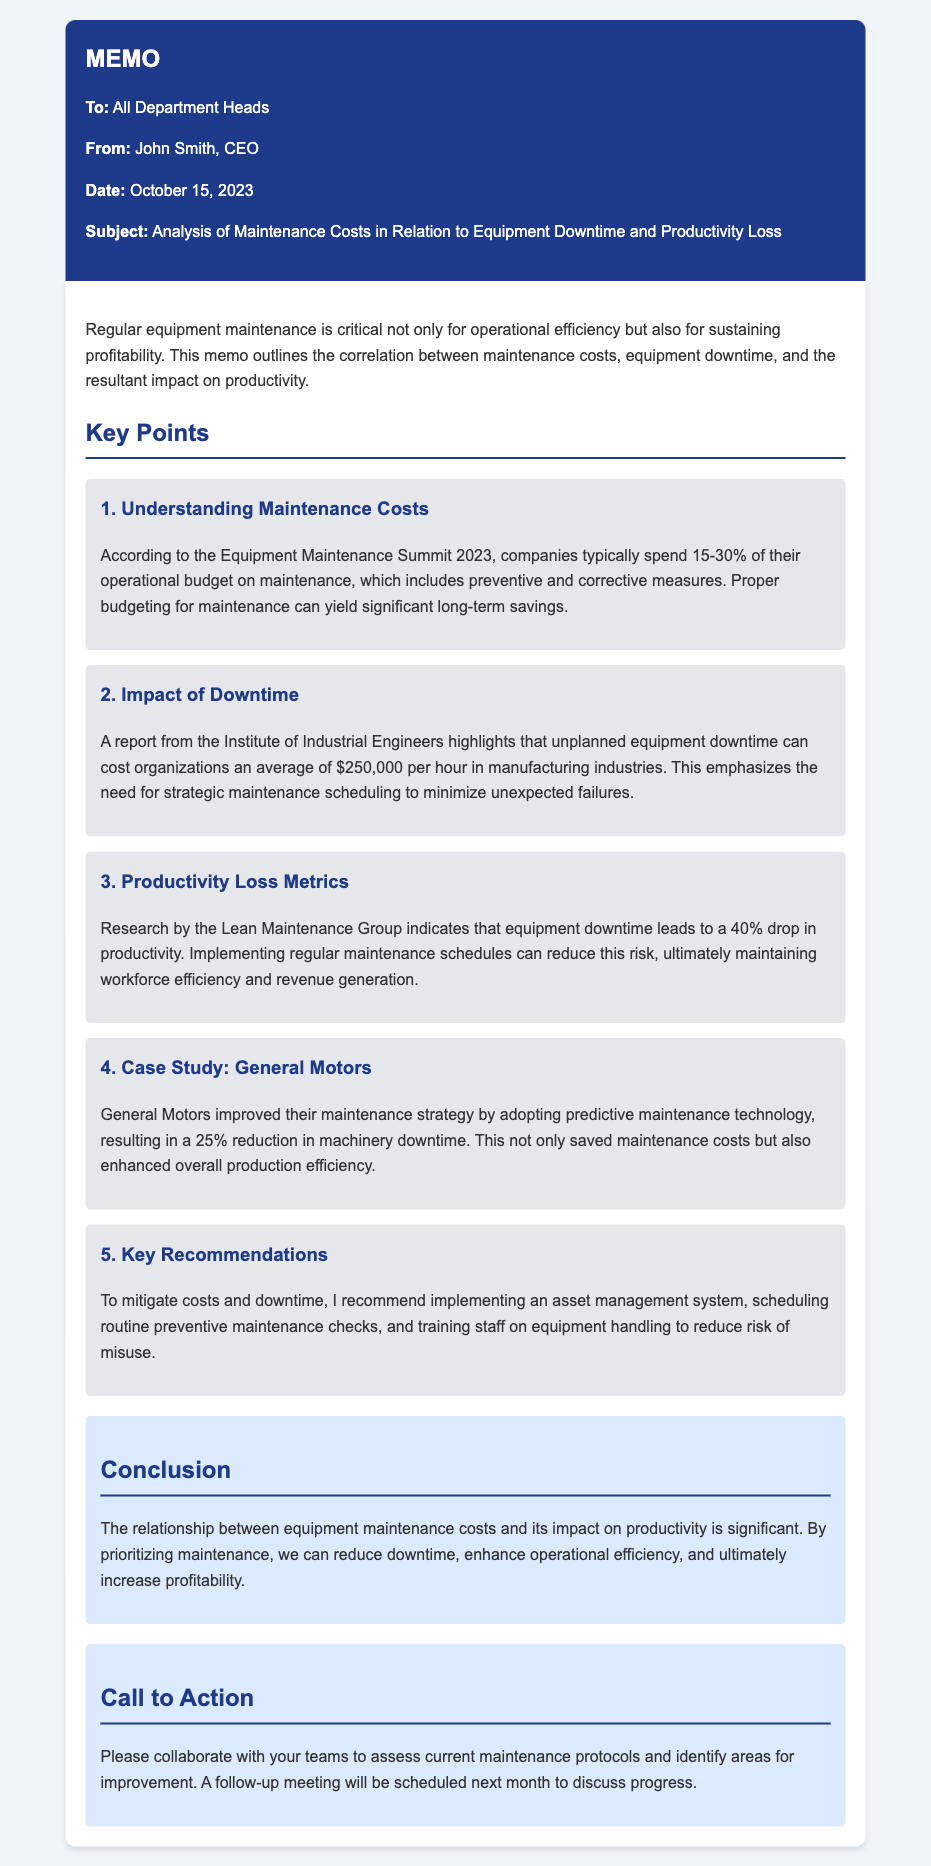What is the date of the memo? The date of the memo is mentioned in the document, which is October 15, 2023.
Answer: October 15, 2023 Who is the author of the memo? The memo states that John Smith is the author.
Answer: John Smith What percentage of the operational budget is typically spent on maintenance? The document mentions that companies typically spend 15-30% of their operational budget on maintenance.
Answer: 15-30% How much can unplanned equipment downtime cost per hour in manufacturing? According to the document, unplanned equipment downtime can cost organizations an average of $250,000 per hour.
Answer: $250,000 What reduction in machinery downtime did General Motors achieve? The case study in the memo indicates that General Motors achieved a 25% reduction in machinery downtime.
Answer: 25% What drop in productivity is caused by equipment downtime? The document states that equipment downtime leads to a 40% drop in productivity.
Answer: 40% What is one key recommendation made in the memo? The memo suggests implementing an asset management system as one of the key recommendations.
Answer: Implementing an asset management system What is the main focus of this memo? The main focus of the memo is the analysis of maintenance costs in relation to equipment downtime and productivity loss.
Answer: Analysis of maintenance costs in relation to equipment downtime and productivity loss What type of maintenance strategy was adopted by General Motors? The memo mentions that General Motors adopted a predictive maintenance technology strategy.
Answer: Predictive maintenance technology 